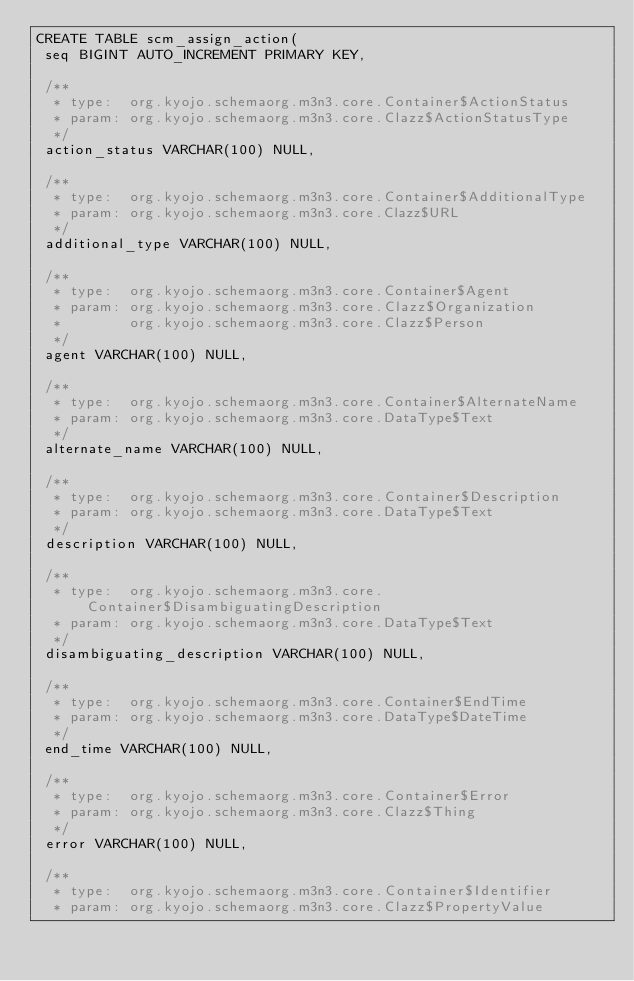<code> <loc_0><loc_0><loc_500><loc_500><_SQL_>CREATE TABLE scm_assign_action(
 seq BIGINT AUTO_INCREMENT PRIMARY KEY,

 /**
  * type:  org.kyojo.schemaorg.m3n3.core.Container$ActionStatus
  * param: org.kyojo.schemaorg.m3n3.core.Clazz$ActionStatusType
  */
 action_status VARCHAR(100) NULL,

 /**
  * type:  org.kyojo.schemaorg.m3n3.core.Container$AdditionalType
  * param: org.kyojo.schemaorg.m3n3.core.Clazz$URL
  */
 additional_type VARCHAR(100) NULL,

 /**
  * type:  org.kyojo.schemaorg.m3n3.core.Container$Agent
  * param: org.kyojo.schemaorg.m3n3.core.Clazz$Organization
  *        org.kyojo.schemaorg.m3n3.core.Clazz$Person
  */
 agent VARCHAR(100) NULL,

 /**
  * type:  org.kyojo.schemaorg.m3n3.core.Container$AlternateName
  * param: org.kyojo.schemaorg.m3n3.core.DataType$Text
  */
 alternate_name VARCHAR(100) NULL,

 /**
  * type:  org.kyojo.schemaorg.m3n3.core.Container$Description
  * param: org.kyojo.schemaorg.m3n3.core.DataType$Text
  */
 description VARCHAR(100) NULL,

 /**
  * type:  org.kyojo.schemaorg.m3n3.core.Container$DisambiguatingDescription
  * param: org.kyojo.schemaorg.m3n3.core.DataType$Text
  */
 disambiguating_description VARCHAR(100) NULL,

 /**
  * type:  org.kyojo.schemaorg.m3n3.core.Container$EndTime
  * param: org.kyojo.schemaorg.m3n3.core.DataType$DateTime
  */
 end_time VARCHAR(100) NULL,

 /**
  * type:  org.kyojo.schemaorg.m3n3.core.Container$Error
  * param: org.kyojo.schemaorg.m3n3.core.Clazz$Thing
  */
 error VARCHAR(100) NULL,

 /**
  * type:  org.kyojo.schemaorg.m3n3.core.Container$Identifier
  * param: org.kyojo.schemaorg.m3n3.core.Clazz$PropertyValue</code> 